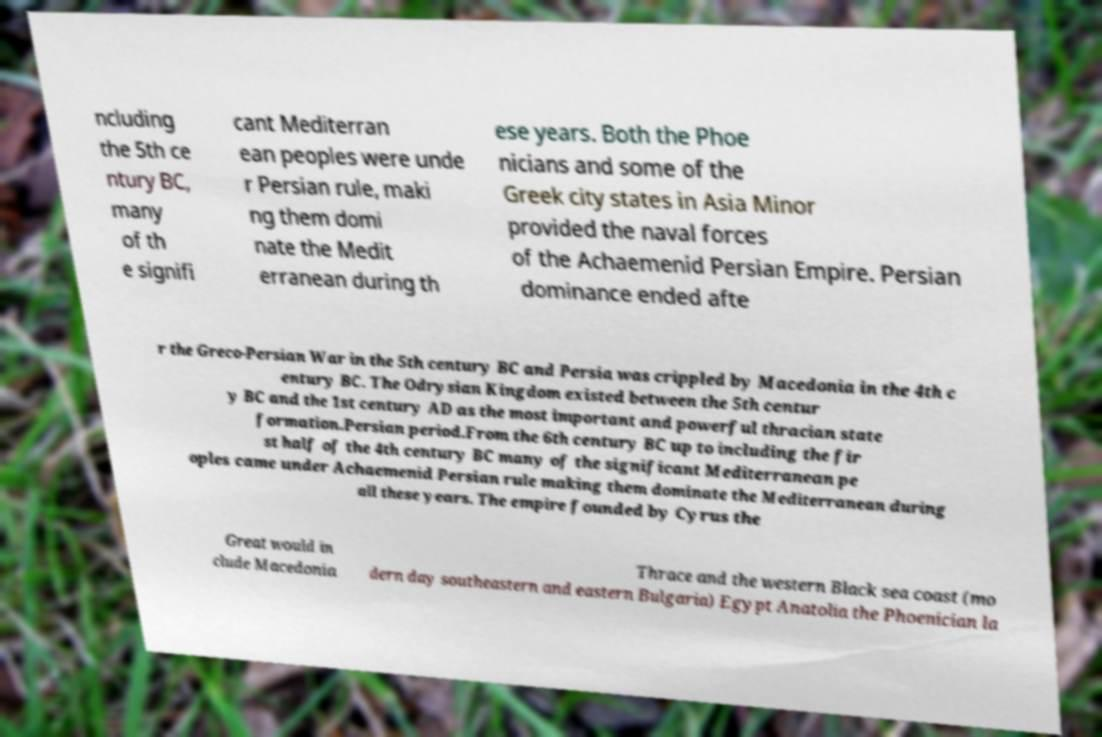What messages or text are displayed in this image? I need them in a readable, typed format. ncluding the 5th ce ntury BC, many of th e signifi cant Mediterran ean peoples were unde r Persian rule, maki ng them domi nate the Medit erranean during th ese years. Both the Phoe nicians and some of the Greek city states in Asia Minor provided the naval forces of the Achaemenid Persian Empire. Persian dominance ended afte r the Greco-Persian War in the 5th century BC and Persia was crippled by Macedonia in the 4th c entury BC. The Odrysian Kingdom existed between the 5th centur y BC and the 1st century AD as the most important and powerful thracian state formation.Persian period.From the 6th century BC up to including the fir st half of the 4th century BC many of the significant Mediterranean pe oples came under Achaemenid Persian rule making them dominate the Mediterranean during all these years. The empire founded by Cyrus the Great would in clude Macedonia Thrace and the western Black sea coast (mo dern day southeastern and eastern Bulgaria) Egypt Anatolia the Phoenician la 